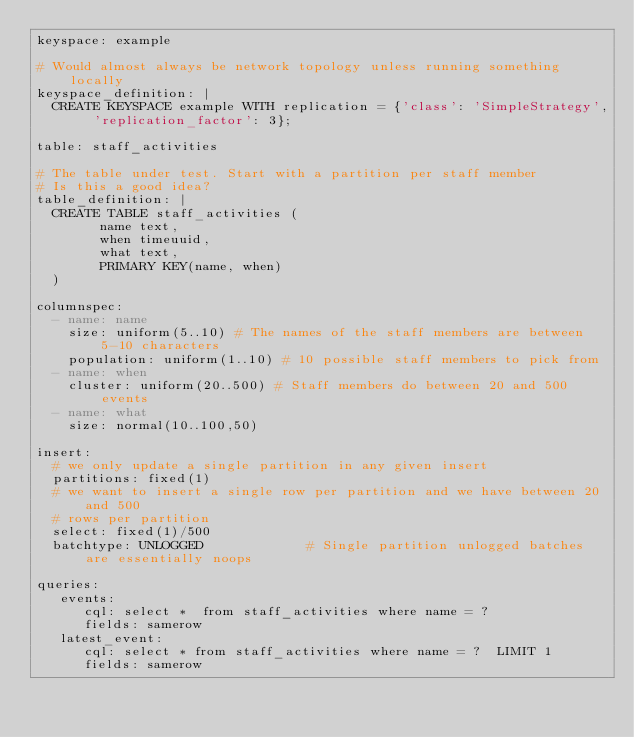<code> <loc_0><loc_0><loc_500><loc_500><_YAML_>keyspace: example

# Would almost always be network topology unless running something locally
keyspace_definition: |
  CREATE KEYSPACE example WITH replication = {'class': 'SimpleStrategy', 'replication_factor': 3};

table: staff_activities

# The table under test. Start with a partition per staff member
# Is this a good idea?
table_definition: |
  CREATE TABLE staff_activities (
        name text,
        when timeuuid,
        what text,
        PRIMARY KEY(name, when)
  ) 

columnspec:
  - name: name
    size: uniform(5..10) # The names of the staff members are between 5-10 characters
    population: uniform(1..10) # 10 possible staff members to pick from 
  - name: when
    cluster: uniform(20..500) # Staff members do between 20 and 500 events
  - name: what
    size: normal(10..100,50)

insert:
  # we only update a single partition in any given insert 
  partitions: fixed(1) 
  # we want to insert a single row per partition and we have between 20 and 500
  # rows per partition
  select: fixed(1)/500 
  batchtype: UNLOGGED             # Single partition unlogged batches are essentially noops

queries:
   events:
      cql: select *  from staff_activities where name = ?
      fields: samerow
   latest_event:
      cql: select * from staff_activities where name = ?  LIMIT 1
      fields: samerow

</code> 